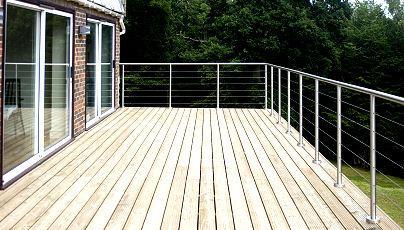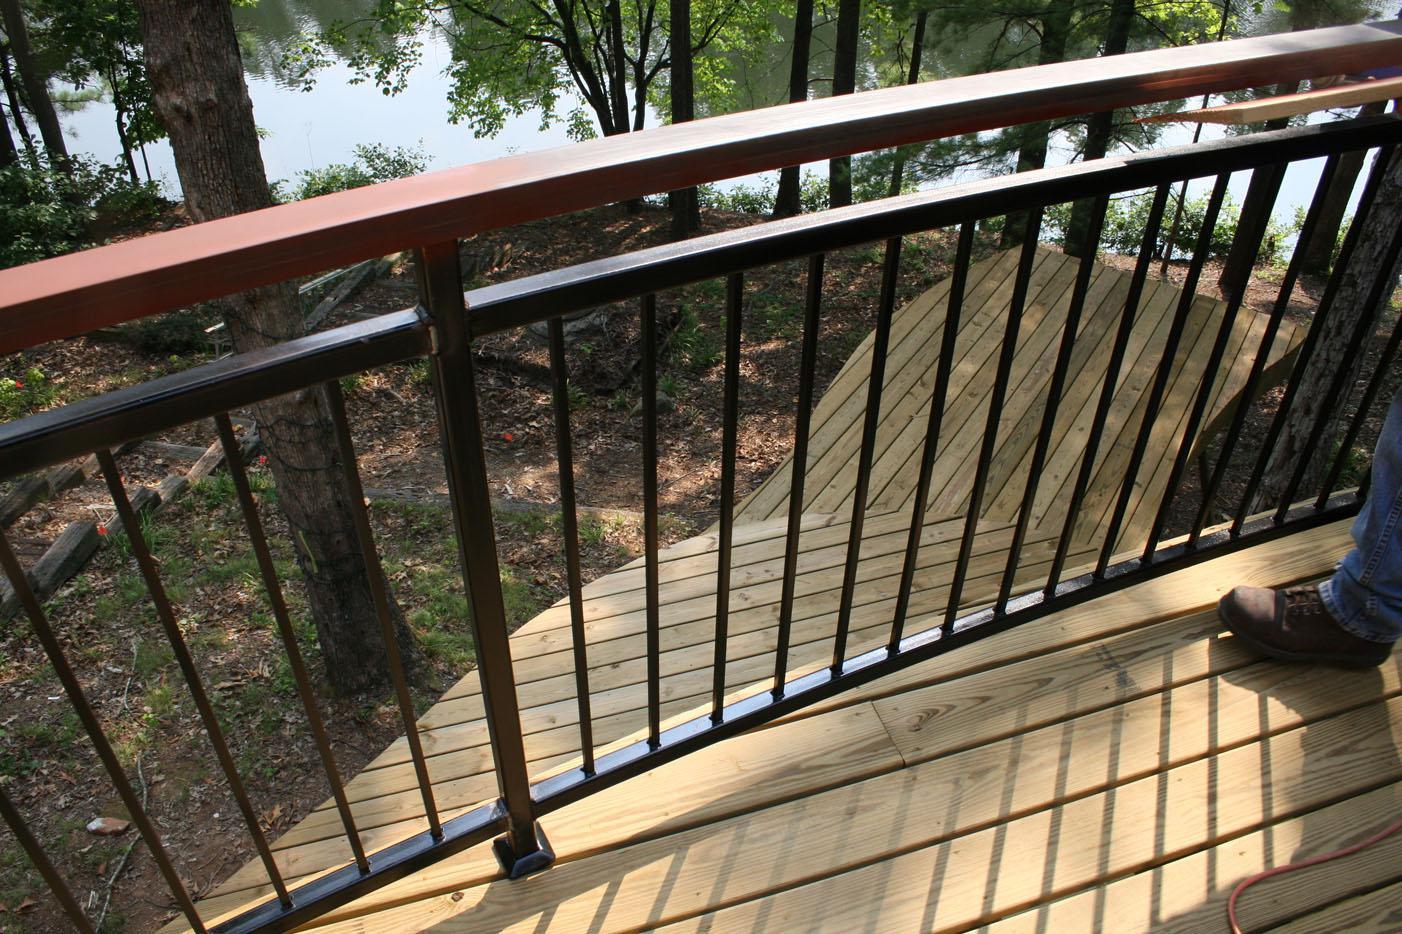The first image is the image on the left, the second image is the image on the right. Assess this claim about the two images: "Flowers and foliage are seen through curving black vertical rails mounted to light wood in both scenes.". Correct or not? Answer yes or no. No. 